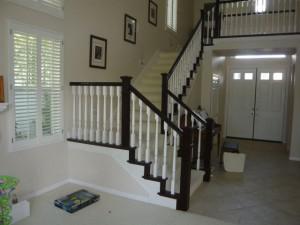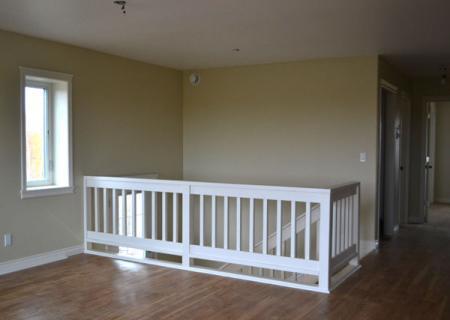The first image is the image on the left, the second image is the image on the right. For the images shown, is this caption "In at least one image there is a stair cause with dark colored trim and white rods." true? Answer yes or no. Yes. The first image is the image on the left, the second image is the image on the right. Given the left and right images, does the statement "Framed pictures line the stairway in one of the images." hold true? Answer yes or no. Yes. 